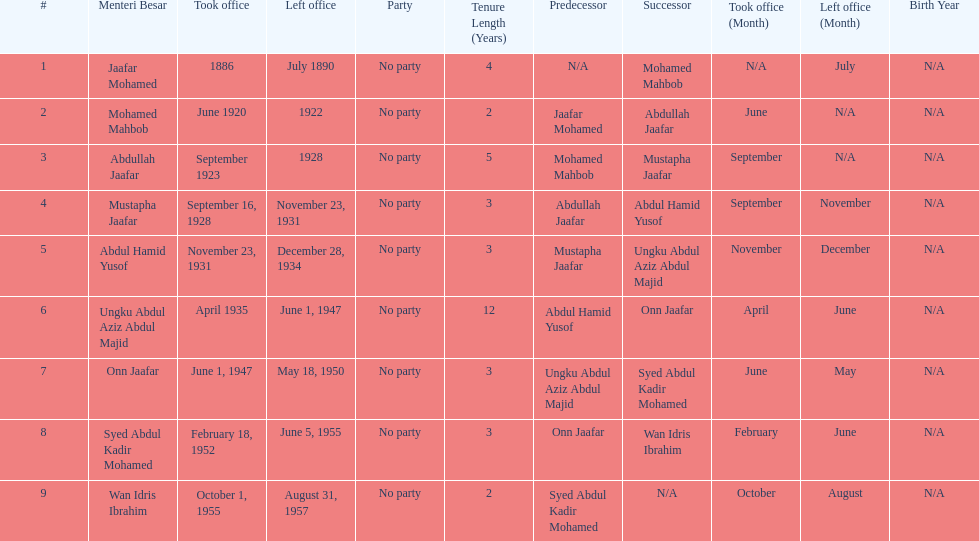When did jaafar mohamed take office? 1886. When did mohamed mahbob take office? June 1920. Who was in office no more than 4 years? Mohamed Mahbob. 